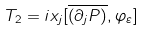<formula> <loc_0><loc_0><loc_500><loc_500>T _ { 2 } = i x _ { j } [ \overline { \left ( \partial _ { j } P \right ) } , \varphi _ { \varepsilon } ]</formula> 